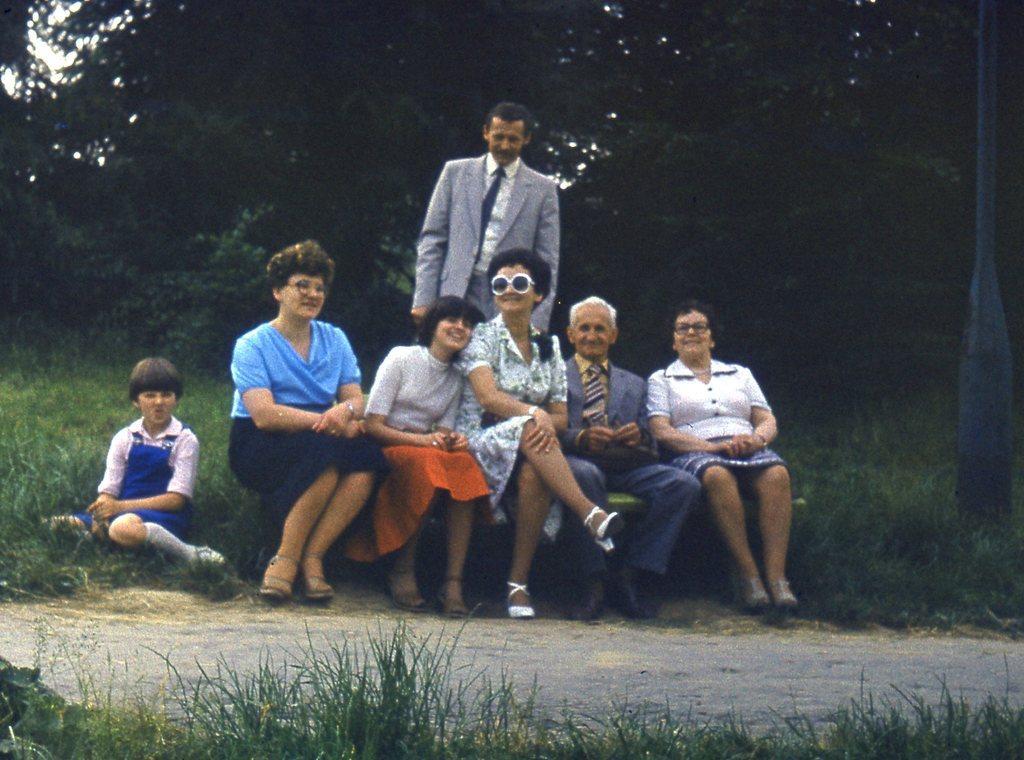How would you summarize this image in a sentence or two? In this image I can see group of people sitting, background I can see a person standing wearing gray blazer, white shirt and I can see trees in green color and sky in white color. 